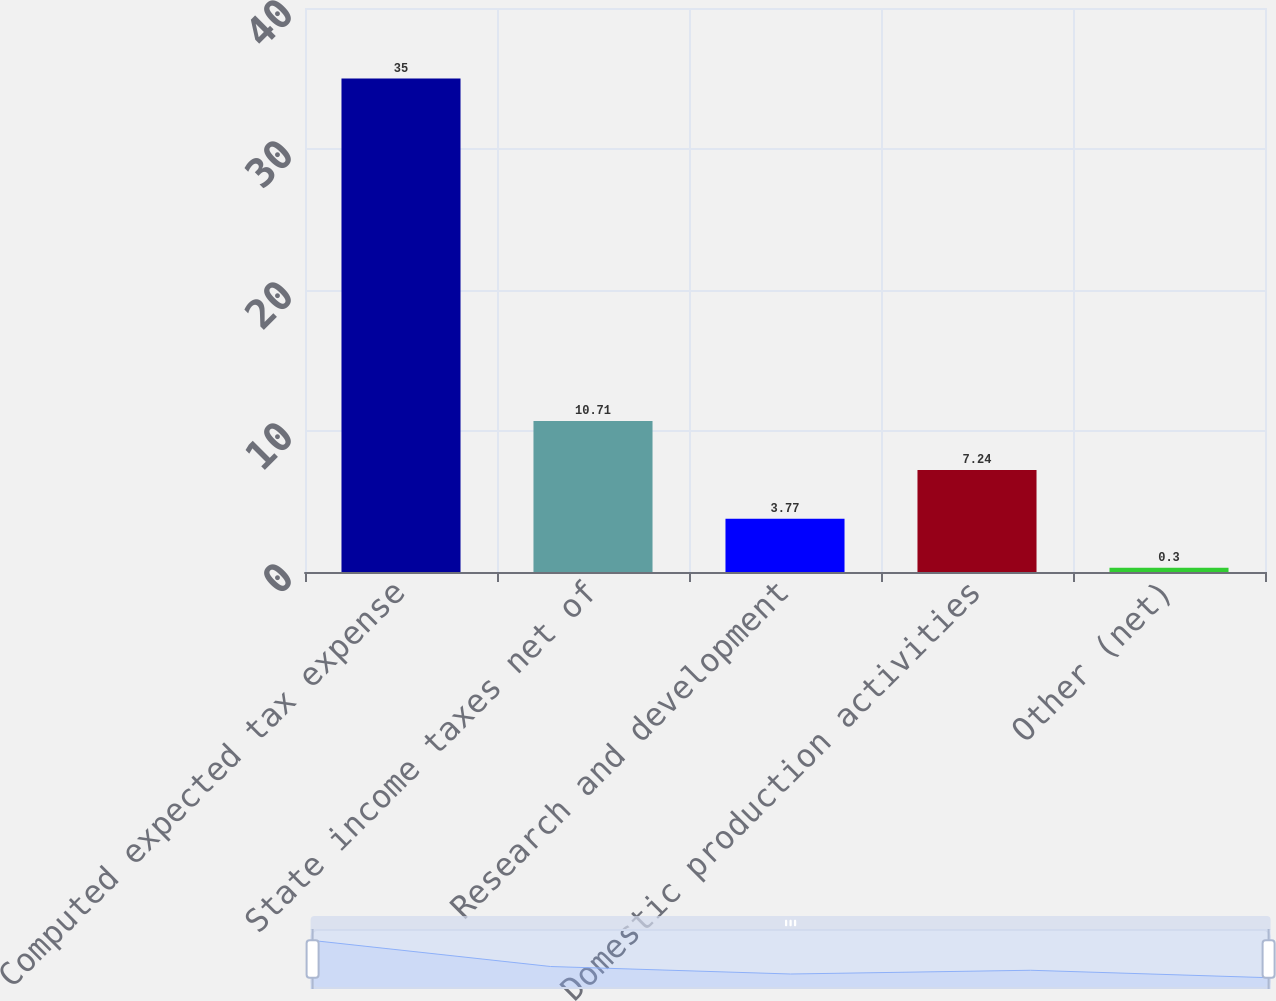Convert chart to OTSL. <chart><loc_0><loc_0><loc_500><loc_500><bar_chart><fcel>Computed expected tax expense<fcel>State income taxes net of<fcel>Research and development<fcel>Domestic production activities<fcel>Other (net)<nl><fcel>35<fcel>10.71<fcel>3.77<fcel>7.24<fcel>0.3<nl></chart> 